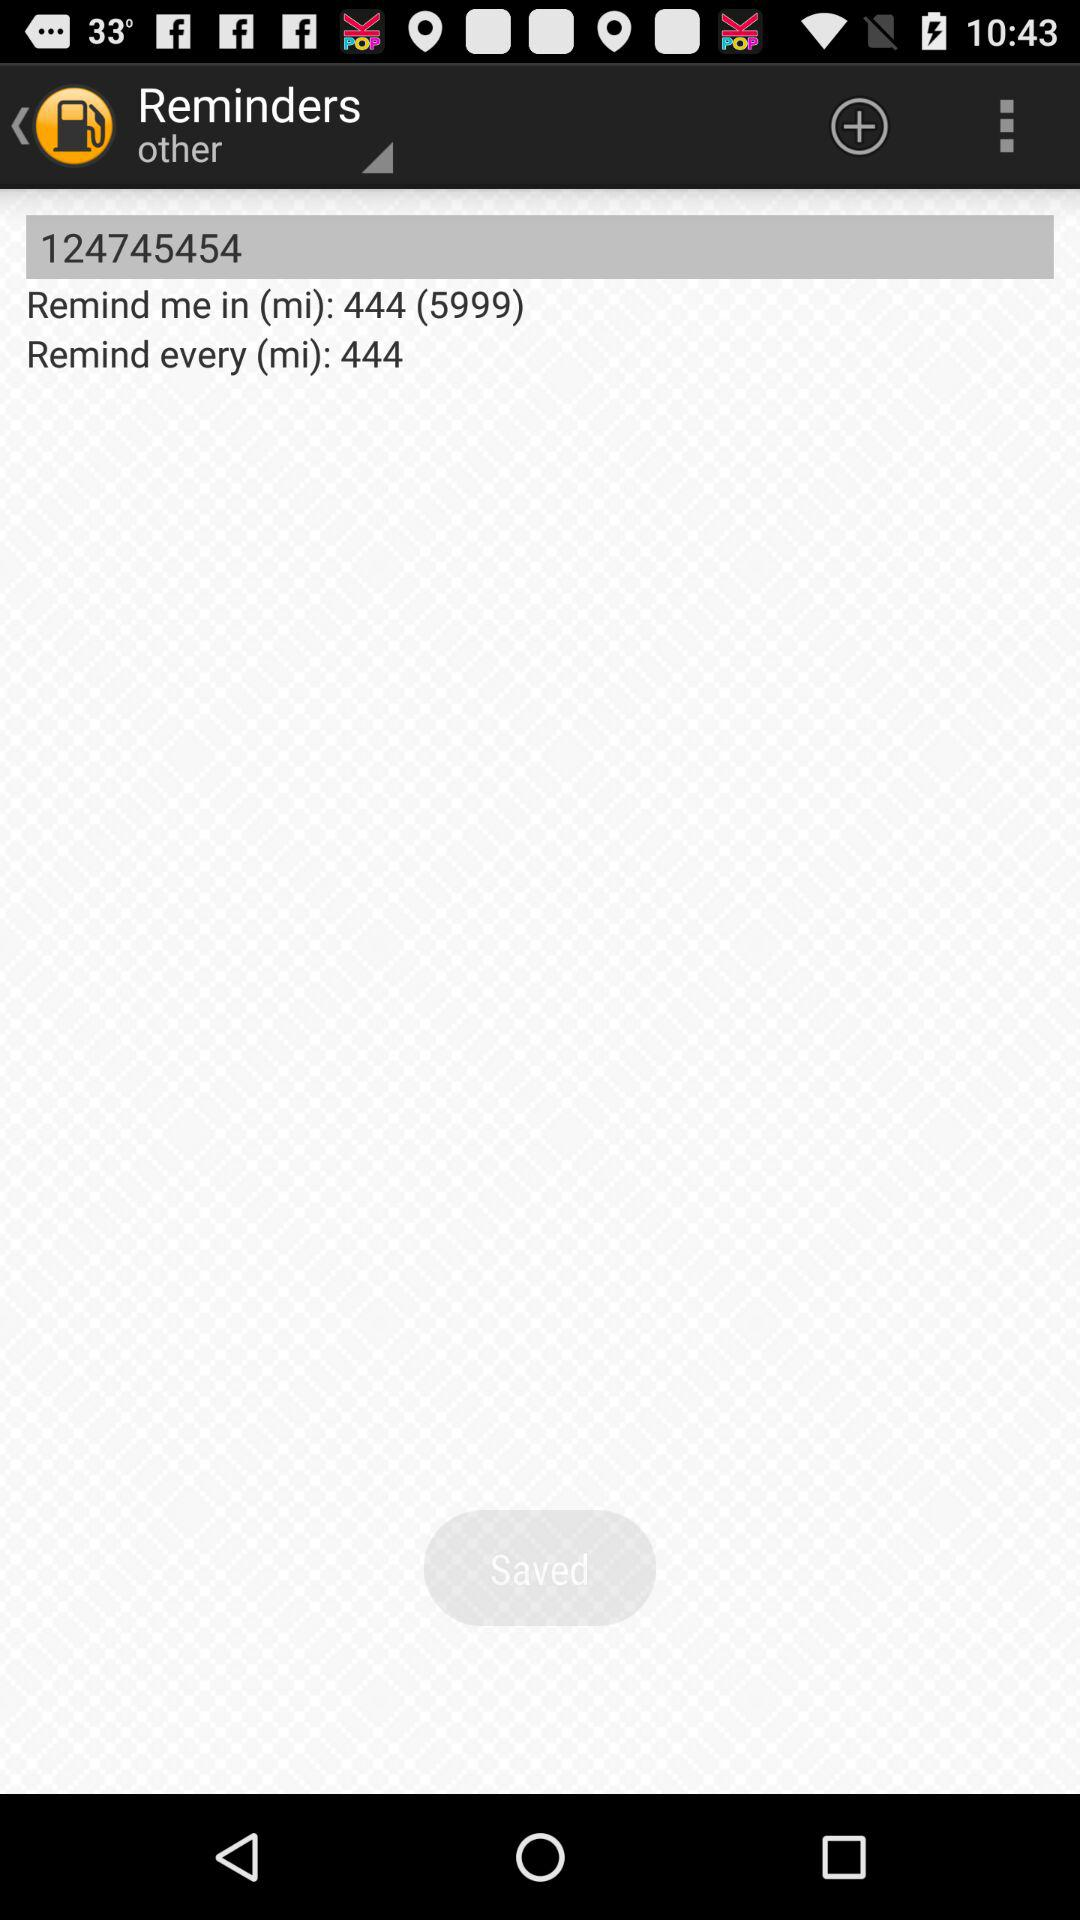How many minutes does the user want to be reminded every?
Answer the question using a single word or phrase. 444 